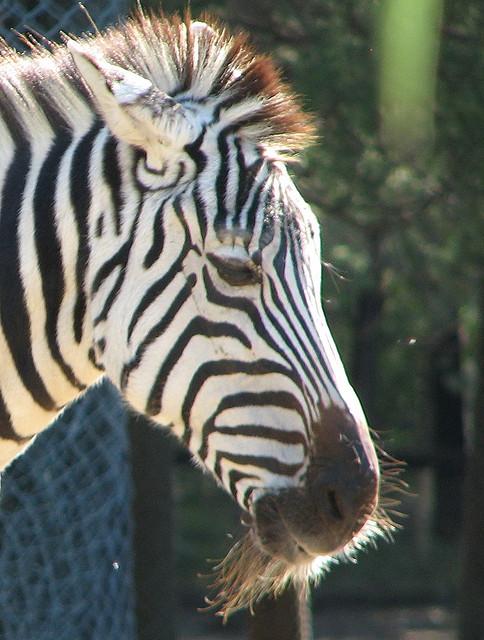How old is the zebra?
Answer briefly. Old. What do you call the hair on the lower mouth of the zebra?
Give a very brief answer. Beard. What species Zebra is this?
Concise answer only. African. 